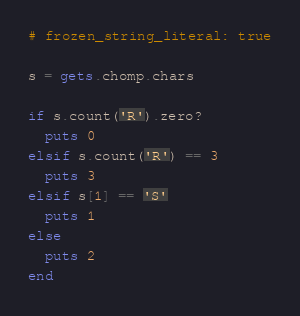<code> <loc_0><loc_0><loc_500><loc_500><_Ruby_># frozen_string_literal: true

s = gets.chomp.chars

if s.count('R').zero?
  puts 0
elsif s.count('R') == 3
  puts 3
elsif s[1] == 'S'
  puts 1
else
  puts 2
end
</code> 